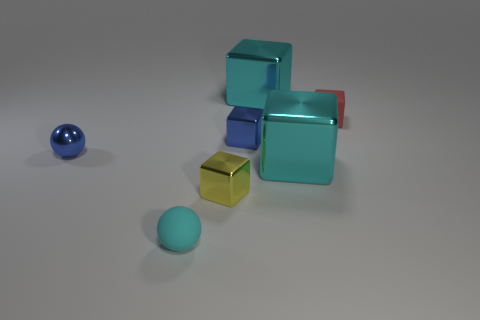Subtract 2 cubes. How many cubes are left? 3 Subtract all yellow metallic blocks. How many blocks are left? 4 Subtract all red cubes. How many cubes are left? 4 Subtract all green blocks. Subtract all brown balls. How many blocks are left? 5 Add 3 large cyan blocks. How many objects exist? 10 Subtract all balls. How many objects are left? 5 Subtract all metal blocks. Subtract all big cyan objects. How many objects are left? 1 Add 1 small cyan things. How many small cyan things are left? 2 Add 3 yellow rubber spheres. How many yellow rubber spheres exist? 3 Subtract 1 cyan blocks. How many objects are left? 6 